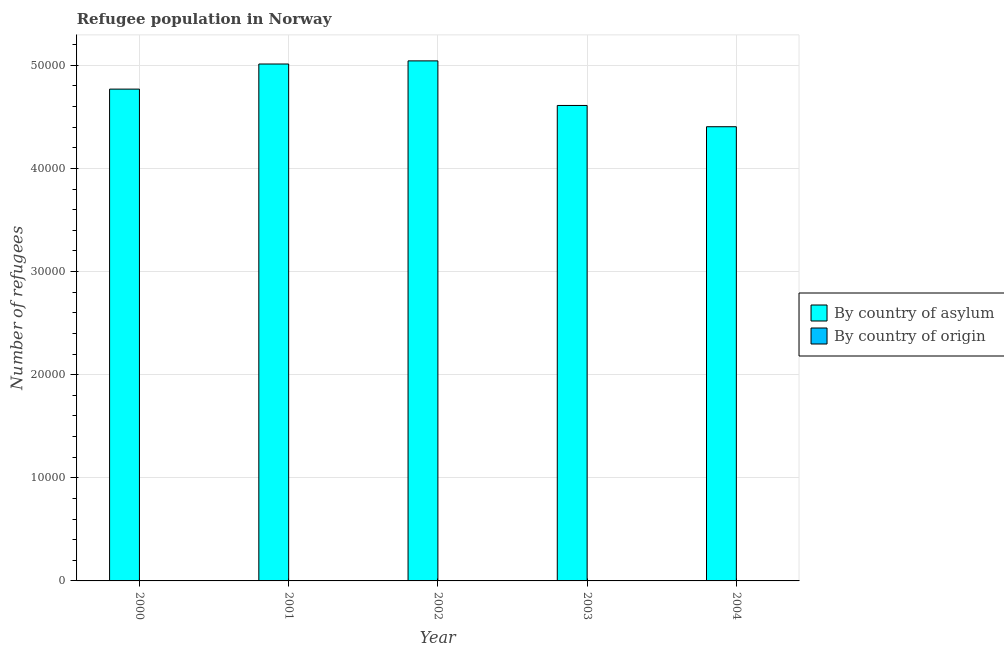How many different coloured bars are there?
Your answer should be very brief. 2. Are the number of bars per tick equal to the number of legend labels?
Give a very brief answer. Yes. In how many cases, is the number of bars for a given year not equal to the number of legend labels?
Provide a short and direct response. 0. What is the number of refugees by country of asylum in 2000?
Keep it short and to the point. 4.77e+04. Across all years, what is the maximum number of refugees by country of origin?
Keep it short and to the point. 15. Across all years, what is the minimum number of refugees by country of origin?
Your response must be concise. 3. What is the total number of refugees by country of asylum in the graph?
Offer a terse response. 2.38e+05. What is the difference between the number of refugees by country of origin in 2003 and that in 2004?
Your answer should be very brief. -1. What is the difference between the number of refugees by country of asylum in 2001 and the number of refugees by country of origin in 2003?
Make the answer very short. 4019. What is the average number of refugees by country of origin per year?
Provide a short and direct response. 6.2. What is the ratio of the number of refugees by country of origin in 2000 to that in 2003?
Ensure brevity in your answer.  1.67. Is the number of refugees by country of asylum in 2001 less than that in 2002?
Provide a succinct answer. Yes. Is the difference between the number of refugees by country of origin in 2000 and 2001 greater than the difference between the number of refugees by country of asylum in 2000 and 2001?
Ensure brevity in your answer.  No. What is the difference between the highest and the second highest number of refugees by country of asylum?
Your answer should be very brief. 304. What is the difference between the highest and the lowest number of refugees by country of origin?
Ensure brevity in your answer.  12. In how many years, is the number of refugees by country of origin greater than the average number of refugees by country of origin taken over all years?
Your response must be concise. 1. What does the 2nd bar from the left in 2003 represents?
Keep it short and to the point. By country of origin. What does the 2nd bar from the right in 2002 represents?
Provide a succinct answer. By country of asylum. Are all the bars in the graph horizontal?
Offer a very short reply. No. How many years are there in the graph?
Offer a terse response. 5. What is the difference between two consecutive major ticks on the Y-axis?
Provide a short and direct response. 10000. Does the graph contain any zero values?
Offer a terse response. No. How many legend labels are there?
Provide a short and direct response. 2. How are the legend labels stacked?
Provide a succinct answer. Vertical. What is the title of the graph?
Ensure brevity in your answer.  Refugee population in Norway. What is the label or title of the X-axis?
Make the answer very short. Year. What is the label or title of the Y-axis?
Provide a succinct answer. Number of refugees. What is the Number of refugees of By country of asylum in 2000?
Your response must be concise. 4.77e+04. What is the Number of refugees in By country of asylum in 2001?
Offer a very short reply. 5.01e+04. What is the Number of refugees in By country of origin in 2001?
Give a very brief answer. 15. What is the Number of refugees of By country of asylum in 2002?
Your response must be concise. 5.04e+04. What is the Number of refugees of By country of asylum in 2003?
Your answer should be compact. 4.61e+04. What is the Number of refugees of By country of origin in 2003?
Provide a short and direct response. 3. What is the Number of refugees in By country of asylum in 2004?
Your response must be concise. 4.40e+04. Across all years, what is the maximum Number of refugees of By country of asylum?
Your response must be concise. 5.04e+04. Across all years, what is the minimum Number of refugees of By country of asylum?
Provide a succinct answer. 4.40e+04. Across all years, what is the minimum Number of refugees of By country of origin?
Provide a succinct answer. 3. What is the total Number of refugees of By country of asylum in the graph?
Provide a short and direct response. 2.38e+05. What is the difference between the Number of refugees in By country of asylum in 2000 and that in 2001?
Your answer should be very brief. -2435. What is the difference between the Number of refugees in By country of origin in 2000 and that in 2001?
Provide a succinct answer. -10. What is the difference between the Number of refugees in By country of asylum in 2000 and that in 2002?
Offer a terse response. -2739. What is the difference between the Number of refugees of By country of asylum in 2000 and that in 2003?
Offer a very short reply. 1584. What is the difference between the Number of refugees in By country of origin in 2000 and that in 2003?
Offer a very short reply. 2. What is the difference between the Number of refugees in By country of asylum in 2000 and that in 2004?
Your answer should be compact. 3647. What is the difference between the Number of refugees of By country of asylum in 2001 and that in 2002?
Ensure brevity in your answer.  -304. What is the difference between the Number of refugees in By country of origin in 2001 and that in 2002?
Offer a terse response. 11. What is the difference between the Number of refugees in By country of asylum in 2001 and that in 2003?
Provide a succinct answer. 4019. What is the difference between the Number of refugees of By country of asylum in 2001 and that in 2004?
Provide a succinct answer. 6082. What is the difference between the Number of refugees in By country of asylum in 2002 and that in 2003?
Provide a short and direct response. 4323. What is the difference between the Number of refugees of By country of origin in 2002 and that in 2003?
Ensure brevity in your answer.  1. What is the difference between the Number of refugees of By country of asylum in 2002 and that in 2004?
Make the answer very short. 6386. What is the difference between the Number of refugees in By country of asylum in 2003 and that in 2004?
Your response must be concise. 2063. What is the difference between the Number of refugees of By country of origin in 2003 and that in 2004?
Provide a succinct answer. -1. What is the difference between the Number of refugees of By country of asylum in 2000 and the Number of refugees of By country of origin in 2001?
Your response must be concise. 4.77e+04. What is the difference between the Number of refugees of By country of asylum in 2000 and the Number of refugees of By country of origin in 2002?
Your answer should be compact. 4.77e+04. What is the difference between the Number of refugees in By country of asylum in 2000 and the Number of refugees in By country of origin in 2003?
Keep it short and to the point. 4.77e+04. What is the difference between the Number of refugees of By country of asylum in 2000 and the Number of refugees of By country of origin in 2004?
Keep it short and to the point. 4.77e+04. What is the difference between the Number of refugees in By country of asylum in 2001 and the Number of refugees in By country of origin in 2002?
Offer a terse response. 5.01e+04. What is the difference between the Number of refugees of By country of asylum in 2001 and the Number of refugees of By country of origin in 2003?
Your response must be concise. 5.01e+04. What is the difference between the Number of refugees in By country of asylum in 2001 and the Number of refugees in By country of origin in 2004?
Your response must be concise. 5.01e+04. What is the difference between the Number of refugees of By country of asylum in 2002 and the Number of refugees of By country of origin in 2003?
Make the answer very short. 5.04e+04. What is the difference between the Number of refugees in By country of asylum in 2002 and the Number of refugees in By country of origin in 2004?
Your response must be concise. 5.04e+04. What is the difference between the Number of refugees in By country of asylum in 2003 and the Number of refugees in By country of origin in 2004?
Your response must be concise. 4.61e+04. What is the average Number of refugees of By country of asylum per year?
Keep it short and to the point. 4.77e+04. What is the average Number of refugees of By country of origin per year?
Your answer should be very brief. 6.2. In the year 2000, what is the difference between the Number of refugees of By country of asylum and Number of refugees of By country of origin?
Your answer should be compact. 4.77e+04. In the year 2001, what is the difference between the Number of refugees in By country of asylum and Number of refugees in By country of origin?
Ensure brevity in your answer.  5.01e+04. In the year 2002, what is the difference between the Number of refugees of By country of asylum and Number of refugees of By country of origin?
Keep it short and to the point. 5.04e+04. In the year 2003, what is the difference between the Number of refugees in By country of asylum and Number of refugees in By country of origin?
Your response must be concise. 4.61e+04. In the year 2004, what is the difference between the Number of refugees of By country of asylum and Number of refugees of By country of origin?
Provide a short and direct response. 4.40e+04. What is the ratio of the Number of refugees of By country of asylum in 2000 to that in 2001?
Provide a short and direct response. 0.95. What is the ratio of the Number of refugees in By country of origin in 2000 to that in 2001?
Keep it short and to the point. 0.33. What is the ratio of the Number of refugees of By country of asylum in 2000 to that in 2002?
Give a very brief answer. 0.95. What is the ratio of the Number of refugees in By country of origin in 2000 to that in 2002?
Make the answer very short. 1.25. What is the ratio of the Number of refugees of By country of asylum in 2000 to that in 2003?
Make the answer very short. 1.03. What is the ratio of the Number of refugees of By country of origin in 2000 to that in 2003?
Offer a terse response. 1.67. What is the ratio of the Number of refugees of By country of asylum in 2000 to that in 2004?
Give a very brief answer. 1.08. What is the ratio of the Number of refugees in By country of origin in 2000 to that in 2004?
Offer a terse response. 1.25. What is the ratio of the Number of refugees of By country of asylum in 2001 to that in 2002?
Your response must be concise. 0.99. What is the ratio of the Number of refugees in By country of origin in 2001 to that in 2002?
Make the answer very short. 3.75. What is the ratio of the Number of refugees in By country of asylum in 2001 to that in 2003?
Give a very brief answer. 1.09. What is the ratio of the Number of refugees in By country of origin in 2001 to that in 2003?
Keep it short and to the point. 5. What is the ratio of the Number of refugees in By country of asylum in 2001 to that in 2004?
Ensure brevity in your answer.  1.14. What is the ratio of the Number of refugees in By country of origin in 2001 to that in 2004?
Offer a very short reply. 3.75. What is the ratio of the Number of refugees of By country of asylum in 2002 to that in 2003?
Provide a succinct answer. 1.09. What is the ratio of the Number of refugees in By country of origin in 2002 to that in 2003?
Make the answer very short. 1.33. What is the ratio of the Number of refugees in By country of asylum in 2002 to that in 2004?
Offer a terse response. 1.15. What is the ratio of the Number of refugees in By country of origin in 2002 to that in 2004?
Offer a very short reply. 1. What is the ratio of the Number of refugees in By country of asylum in 2003 to that in 2004?
Offer a terse response. 1.05. What is the difference between the highest and the second highest Number of refugees of By country of asylum?
Make the answer very short. 304. What is the difference between the highest and the lowest Number of refugees of By country of asylum?
Offer a terse response. 6386. What is the difference between the highest and the lowest Number of refugees of By country of origin?
Provide a succinct answer. 12. 